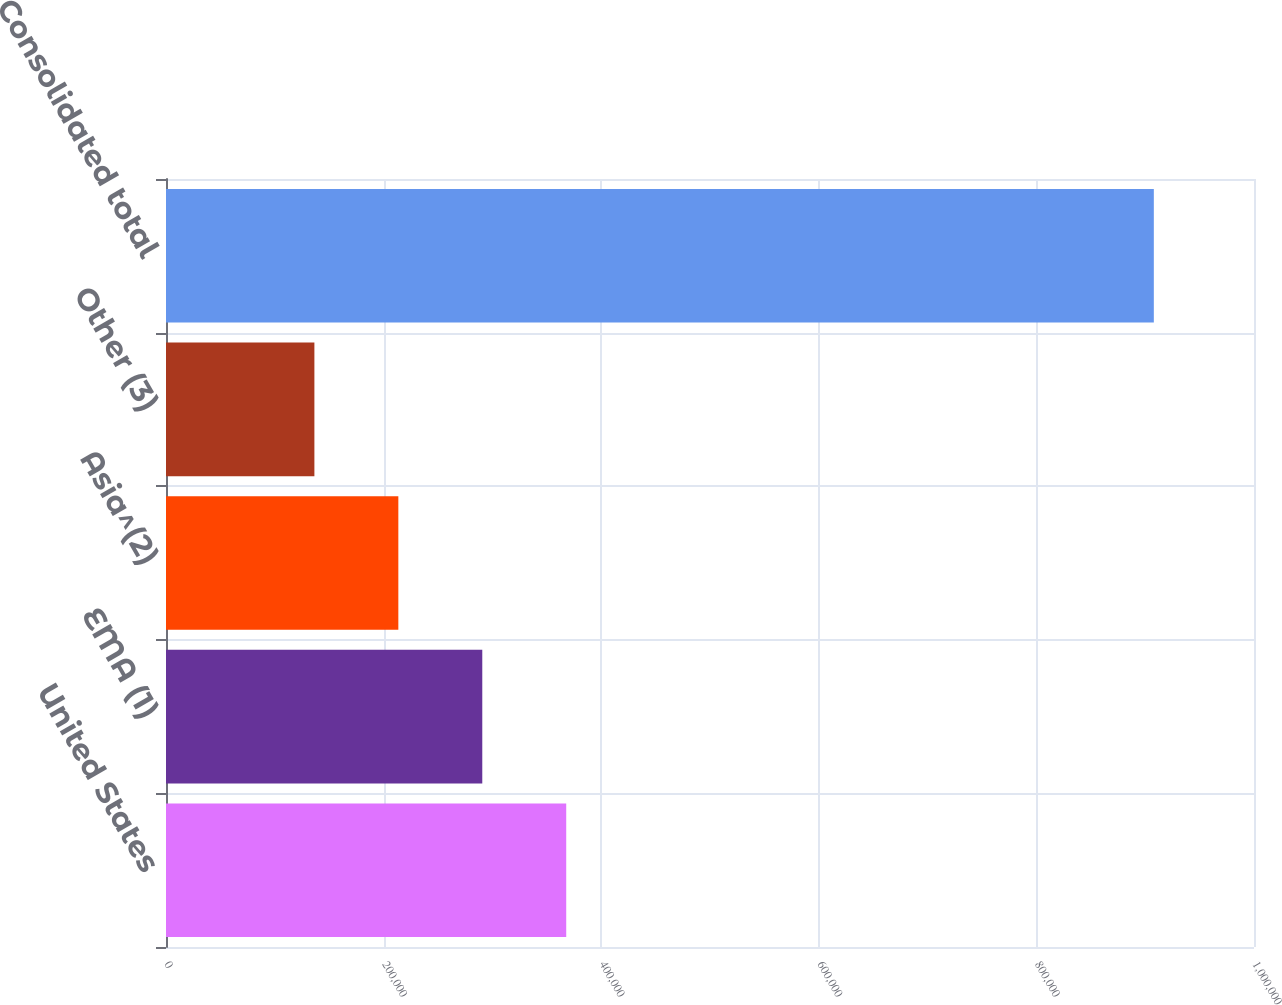<chart> <loc_0><loc_0><loc_500><loc_500><bar_chart><fcel>United States<fcel>EMA (1)<fcel>Asia^(2)<fcel>Other (3)<fcel>Consolidated total<nl><fcel>367853<fcel>290699<fcel>213545<fcel>136391<fcel>907931<nl></chart> 